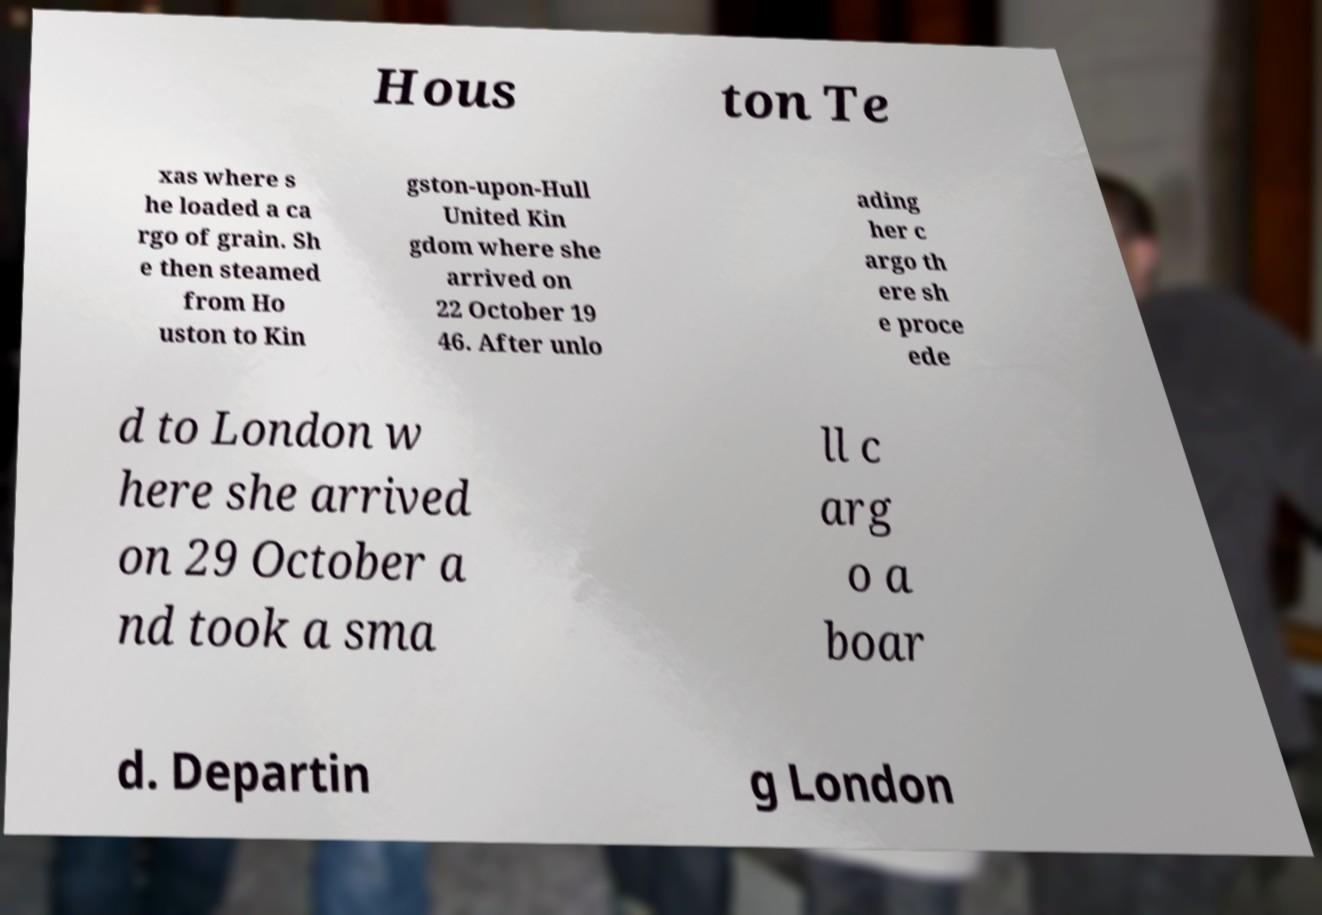There's text embedded in this image that I need extracted. Can you transcribe it verbatim? Hous ton Te xas where s he loaded a ca rgo of grain. Sh e then steamed from Ho uston to Kin gston-upon-Hull United Kin gdom where she arrived on 22 October 19 46. After unlo ading her c argo th ere sh e proce ede d to London w here she arrived on 29 October a nd took a sma ll c arg o a boar d. Departin g London 